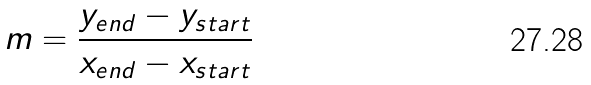Convert formula to latex. <formula><loc_0><loc_0><loc_500><loc_500>m = \frac { y _ { e n d } - y _ { s t a r t } } { x _ { e n d } - x _ { s t a r t } }</formula> 